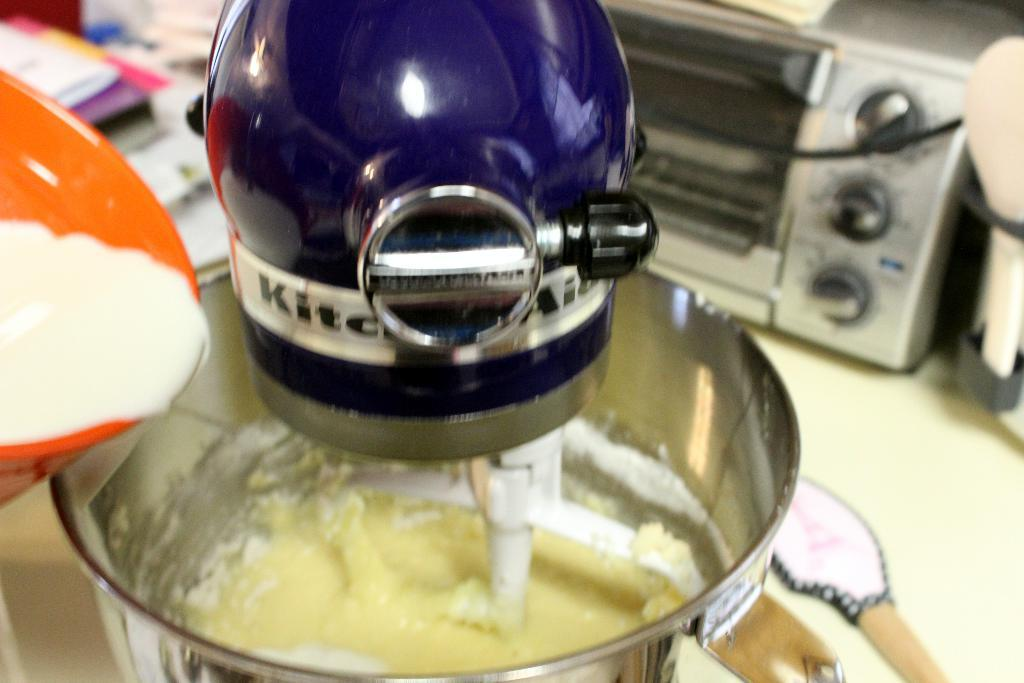What appliance is the main subject of the image? There is a blending machine in the image. What is happening with the blending machine? An item is inside the blending machine, and a dish is being poured into it. What other appliance can be seen in the background of the image? There is an oven in the background of the image. How many sheep are visible in the image? There are no sheep present in the image. What type of riddle can be solved using the ingredients in the blending machine? The image does not provide enough information to create or solve a riddle related to the ingredients in the blending machine. 